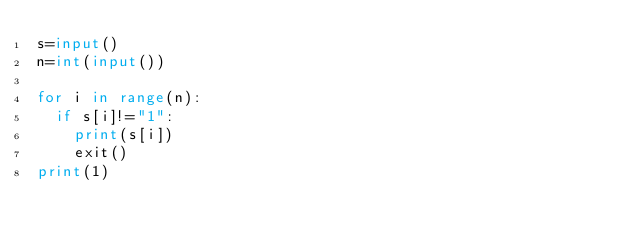Convert code to text. <code><loc_0><loc_0><loc_500><loc_500><_Python_>s=input()
n=int(input())

for i in range(n):
  if s[i]!="1":
    print(s[i])
    exit()
print(1)</code> 